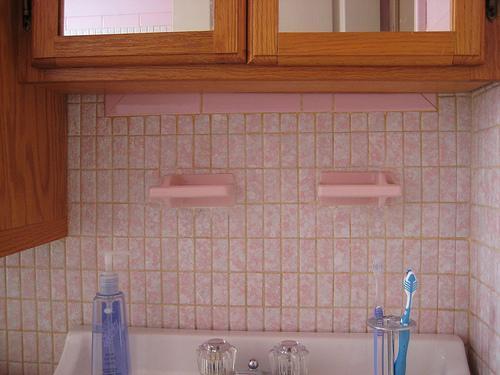How many people are visible?
Give a very brief answer. 0. 